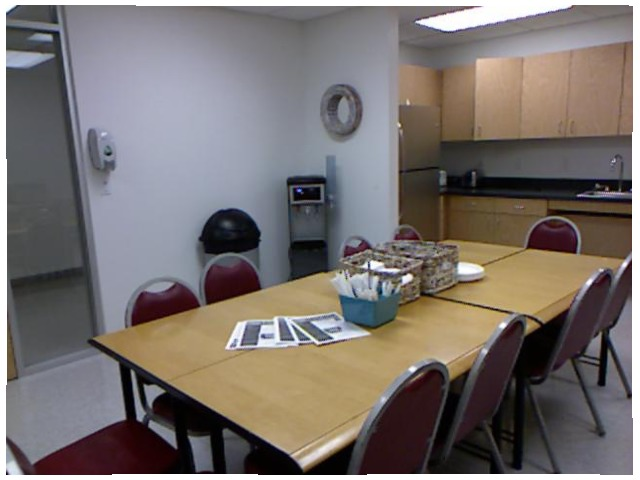<image>
Can you confirm if the chair is in front of the table? Yes. The chair is positioned in front of the table, appearing closer to the camera viewpoint. Is there a utensils on the table? Yes. Looking at the image, I can see the utensils is positioned on top of the table, with the table providing support. Where is the chair in relation to the table? Is it on the table? No. The chair is not positioned on the table. They may be near each other, but the chair is not supported by or resting on top of the table. Is there a chair behind the table? No. The chair is not behind the table. From this viewpoint, the chair appears to be positioned elsewhere in the scene. Is there a chair to the right of the chair? No. The chair is not to the right of the chair. The horizontal positioning shows a different relationship. Where is the cupboard in relation to the light? Is it under the light? Yes. The cupboard is positioned underneath the light, with the light above it in the vertical space. 